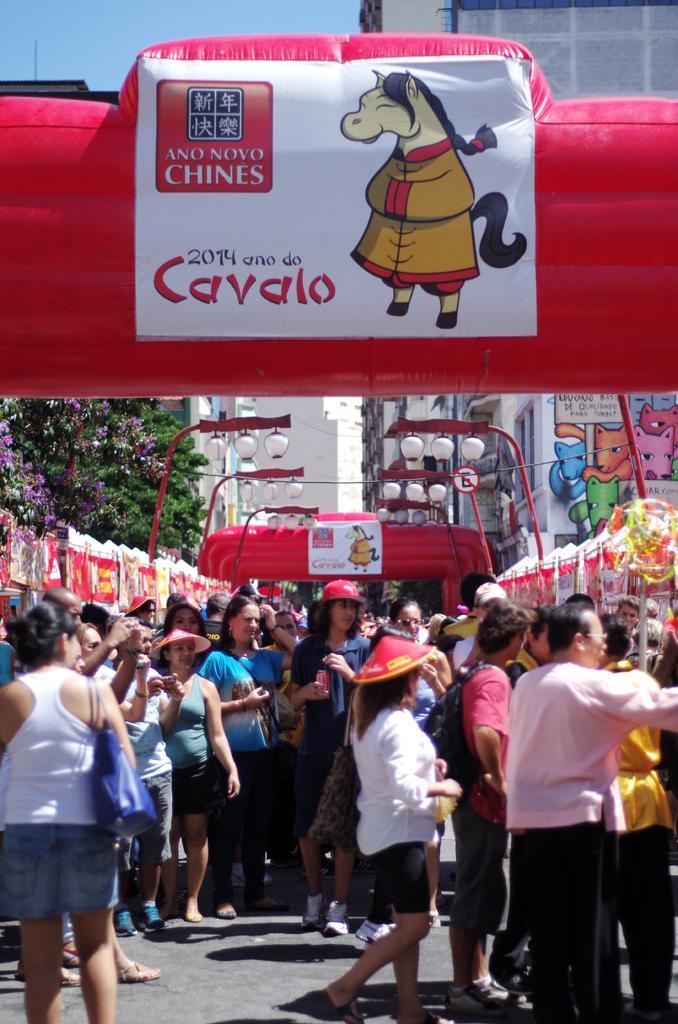In one or two sentences, can you explain what this image depicts? In this image I can see at the bottom a group of people are there, at the top there is the air balloon with a sticker on it. 